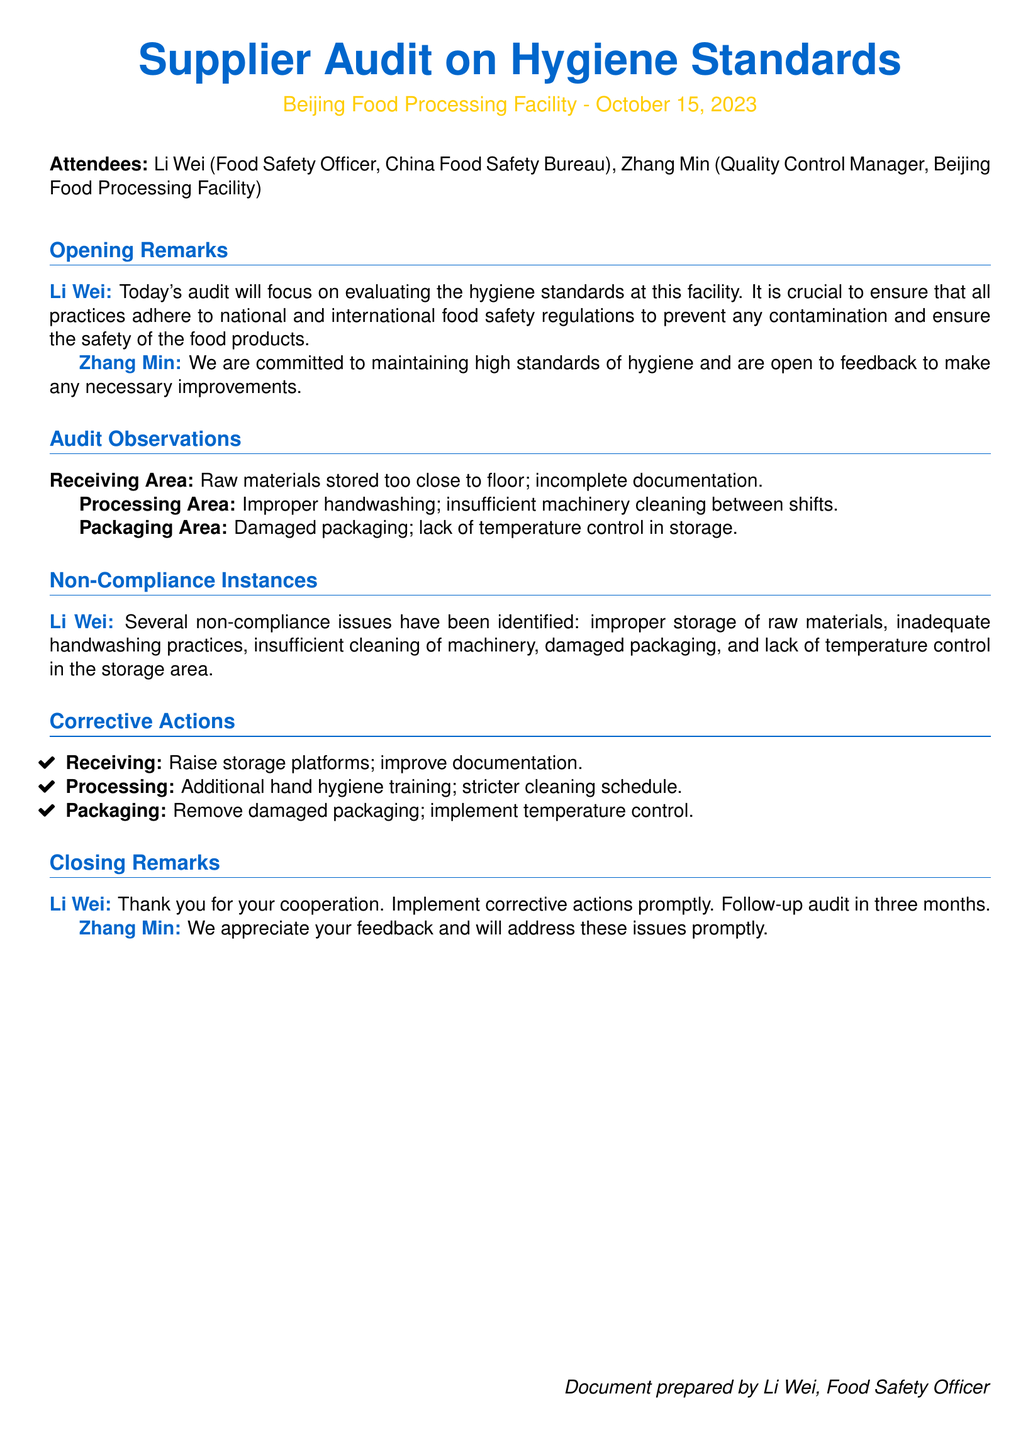What date was the audit conducted? The document specifies that the audit took place on October 15, 2023.
Answer: October 15, 2023 Who conducted the audit? The food safety officer conducting the audit is Li Wei.
Answer: Li Wei What area had improper handwashing noted during the audit? The area with improper handwashing practices was the Processing Area.
Answer: Processing Area How many non-compliance issues were identified? There were five non-compliance issues listed in the document.
Answer: Five What corrective action was suggested for the Receiving area? The suggested corrective action for the Receiving Area is to raise storage platforms.
Answer: Raise storage platforms When is the follow-up audit scheduled? The follow-up audit will take place in three months as stated in the document.
Answer: In three months Who is the Quality Control Manager at the facility? The Quality Control Manager at the Beijing Food Processing Facility is Zhang Min.
Answer: Zhang Min What type of training will be increased as a corrective action? The audit suggests that additional hand hygiene training will be implemented.
Answer: Hand hygiene training 